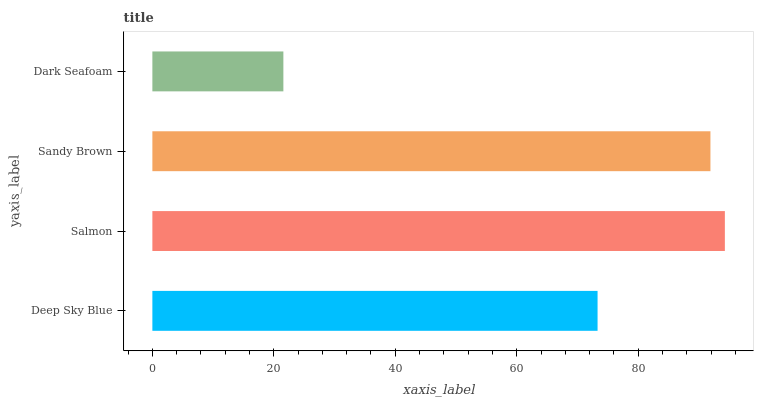Is Dark Seafoam the minimum?
Answer yes or no. Yes. Is Salmon the maximum?
Answer yes or no. Yes. Is Sandy Brown the minimum?
Answer yes or no. No. Is Sandy Brown the maximum?
Answer yes or no. No. Is Salmon greater than Sandy Brown?
Answer yes or no. Yes. Is Sandy Brown less than Salmon?
Answer yes or no. Yes. Is Sandy Brown greater than Salmon?
Answer yes or no. No. Is Salmon less than Sandy Brown?
Answer yes or no. No. Is Sandy Brown the high median?
Answer yes or no. Yes. Is Deep Sky Blue the low median?
Answer yes or no. Yes. Is Deep Sky Blue the high median?
Answer yes or no. No. Is Sandy Brown the low median?
Answer yes or no. No. 